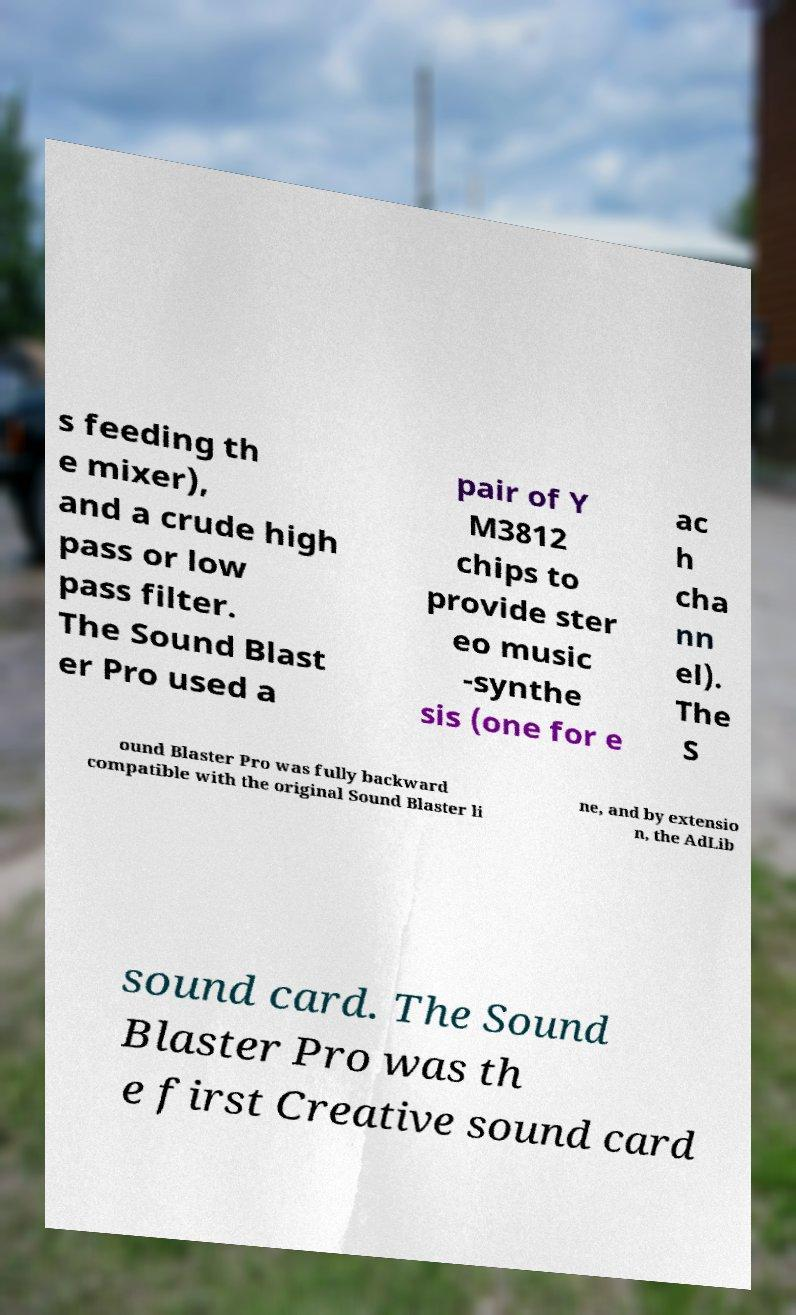Please identify and transcribe the text found in this image. s feeding th e mixer), and a crude high pass or low pass filter. The Sound Blast er Pro used a pair of Y M3812 chips to provide ster eo music -synthe sis (one for e ac h cha nn el). The S ound Blaster Pro was fully backward compatible with the original Sound Blaster li ne, and by extensio n, the AdLib sound card. The Sound Blaster Pro was th e first Creative sound card 